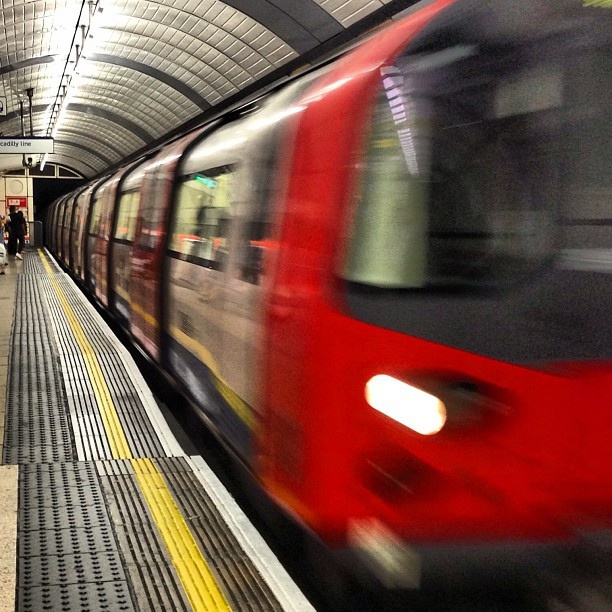Describe the objects in this image and their specific colors. I can see train in darkgray, black, brown, gray, and maroon tones, people in black, maroon, and darkgray tones, and people in darkgray, black, and maroon tones in this image. 